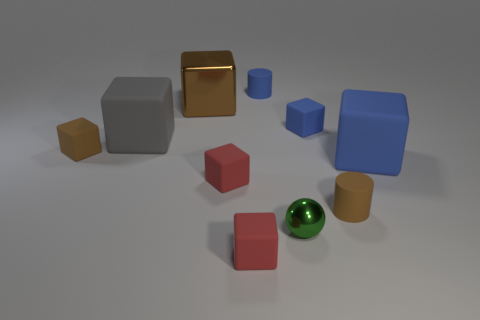Subtract all large brown metal blocks. How many blocks are left? 6 Subtract 1 cubes. How many cubes are left? 6 Subtract all gray cubes. How many cubes are left? 6 Subtract all green blocks. Subtract all cyan cylinders. How many blocks are left? 7 Subtract all balls. How many objects are left? 9 Add 2 blue shiny cylinders. How many blue shiny cylinders exist? 2 Subtract 2 blue cubes. How many objects are left? 8 Subtract all tiny brown rubber objects. Subtract all big blocks. How many objects are left? 5 Add 5 blue matte things. How many blue matte things are left? 8 